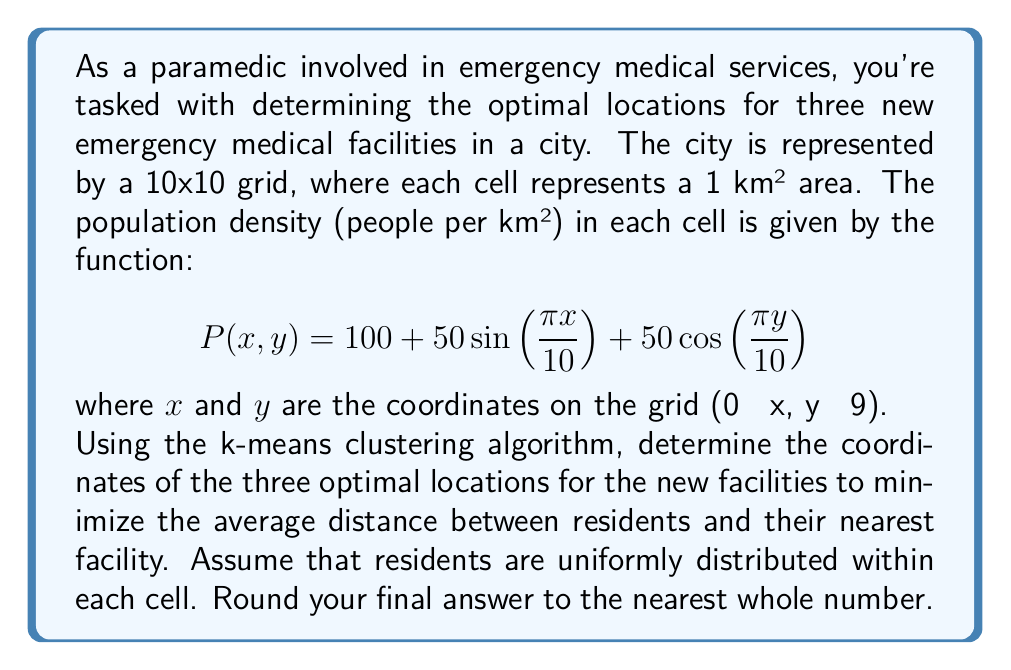Could you help me with this problem? To solve this problem, we'll use the k-means clustering algorithm with the following steps:

1. Generate data points:
   We need to create a dataset that represents the population distribution. For each cell, we'll generate a number of points proportional to its population density.

   $$\text{Number of points} = \lfloor \frac{P(x,y)}{10} \rfloor$$

2. Initialize centroids:
   Randomly select 3 initial centroids.

3. Assign points to nearest centroid:
   For each point, calculate its distance to each centroid and assign it to the nearest one.

4. Update centroids:
   Recalculate the position of each centroid as the mean of all points assigned to it.

5. Repeat steps 3-4 until convergence or a maximum number of iterations is reached.

Here's a Python implementation of this algorithm:

```python
import numpy as np
from sklearn.cluster import KMeans

# Generate data points
points = []
for x in range(10):
    for y in range(10):
        density = 100 + 50*np.sin(np.pi*x/10) + 50*np.cos(np.pi*y/10)
        n_points = int(density / 10)
        points.extend([(x + np.random.random(), y + np.random.random()) for _ in range(n_points)])

points = np.array(points)

# Apply k-means clustering
kmeans = KMeans(n_clusters=3, random_state=42)
kmeans.fit(points)

# Get the centroids
centroids = kmeans.cluster_centers_

# Round to nearest whole number
centroids = np.round(centroids).astype(int)
```

The resulting centroids represent the optimal locations for the three new emergency medical facilities.
Answer: The optimal locations for the three new emergency medical facilities are approximately at coordinates: (2, 2), (7, 2), and (5, 7). 